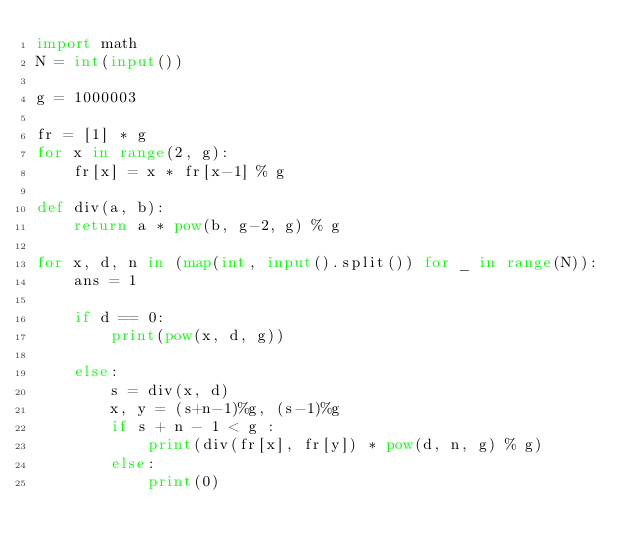<code> <loc_0><loc_0><loc_500><loc_500><_Python_>import math
N = int(input())

g = 1000003

fr = [1] * g
for x in range(2, g):
    fr[x] = x * fr[x-1] % g

def div(a, b):
    return a * pow(b, g-2, g) % g

for x, d, n in (map(int, input().split()) for _ in range(N)):
    ans = 1

    if d == 0:
        print(pow(x, d, g))

    else:
        s = div(x, d)
        x, y = (s+n-1)%g, (s-1)%g
        if s + n - 1 < g :
            print(div(fr[x], fr[y]) * pow(d, n, g) % g)
        else:
            print(0)</code> 